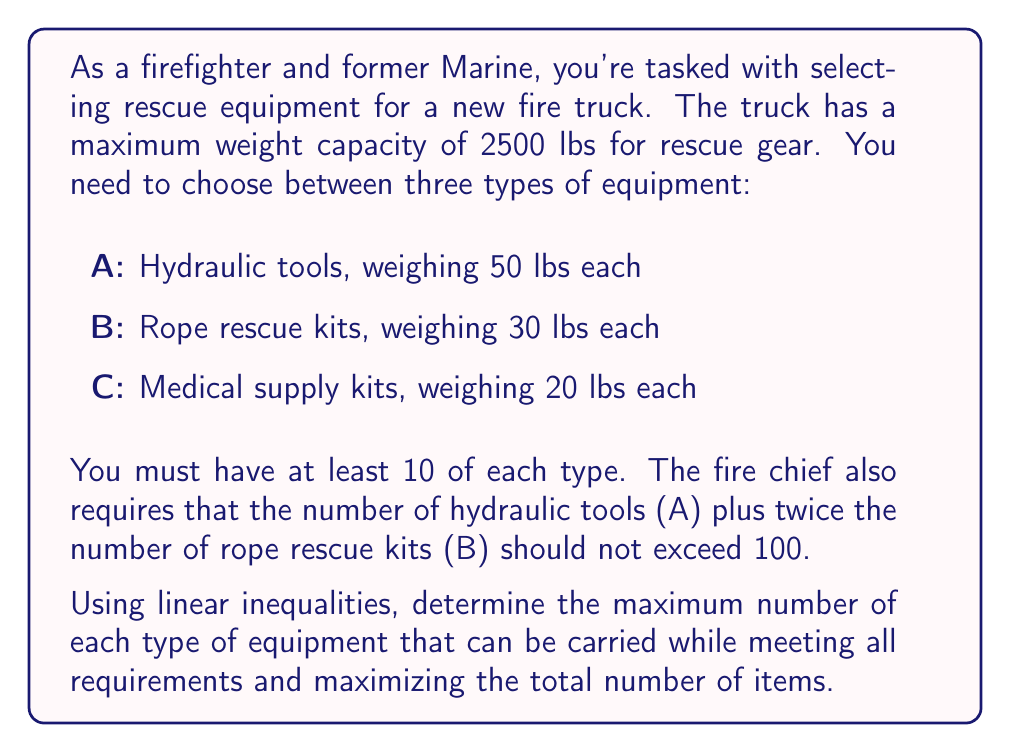Help me with this question. Let's approach this step-by-step:

1) Define variables:
   Let $x$ = number of hydraulic tools (A)
   Let $y$ = number of rope rescue kits (B)
   Let $z$ = number of medical supply kits (C)

2) Set up inequalities based on the given information:

   a) Weight constraint: $50x + 30y + 20z \leq 2500$
   b) Minimum quantity for each type: $x \geq 10$, $y \geq 10$, $z \geq 10$
   c) Fire chief's requirement: $x + 2y \leq 100$

3) Our objective is to maximize $x + y + z$ subject to these constraints.

4) We can simplify by considering the minimum requirements:
   $50(10) + 30(10) + 20(10) = 1000$ lbs are already accounted for.
   This leaves 1500 lbs for additional equipment.

5) Let's rewrite our inequalities with the minimums factored in:
   $50(x-10) + 30(y-10) + 20(z-10) \leq 1500$
   $x-10 \geq 0$, $y-10 \geq 0$, $z-10 \geq 0$
   $(x-10) + 2(y-10) \leq 80$

6) To maximize the total number of items, we should prioritize the lightest items (C), then B, then A.

7) After meeting the minimum requirements, we can add up to 75 more C items:
   $20 * 75 = 1500$
   So $z = 10 + 75 = 85$

8) Now we need to maximize $x + y$ subject to:
   $50(x-10) + 30(y-10) \leq 0$
   $x-10 \geq 0$, $y-10 \geq 0$
   $(x-10) + 2(y-10) \leq 80$

9) To maximize $x + y$, we should make $x-10 + 2(y-10) = 80$
   This gives us $x + 2y = 100$, which matches the fire chief's requirement.

10) Substituting into $50(x-10) + 30(y-10) \leq 0$:
    $50(90-2y) + 30y \leq 500$
    $4500 - 100y + 30y \leq 500$
    $4000 \leq 70y$
    $y \leq 57.14$

11) The maximum integer value for $y$ is 57, which makes $x = 43$.

Therefore, the maximum quantities are:
$x = 43$ (hydraulic tools)
$y = 57$ (rope rescue kits)
$z = 85$ (medical supply kits)
Answer: 43 hydraulic tools, 57 rope rescue kits, 85 medical supply kits 